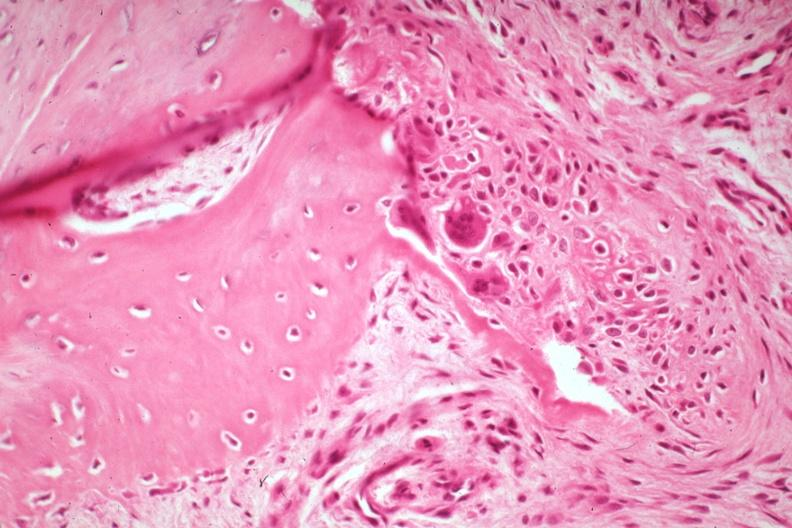how does this image show high excellent osteoid deposition?
Answer the question using a single word or phrase. With osteoclasts there is a fracture 